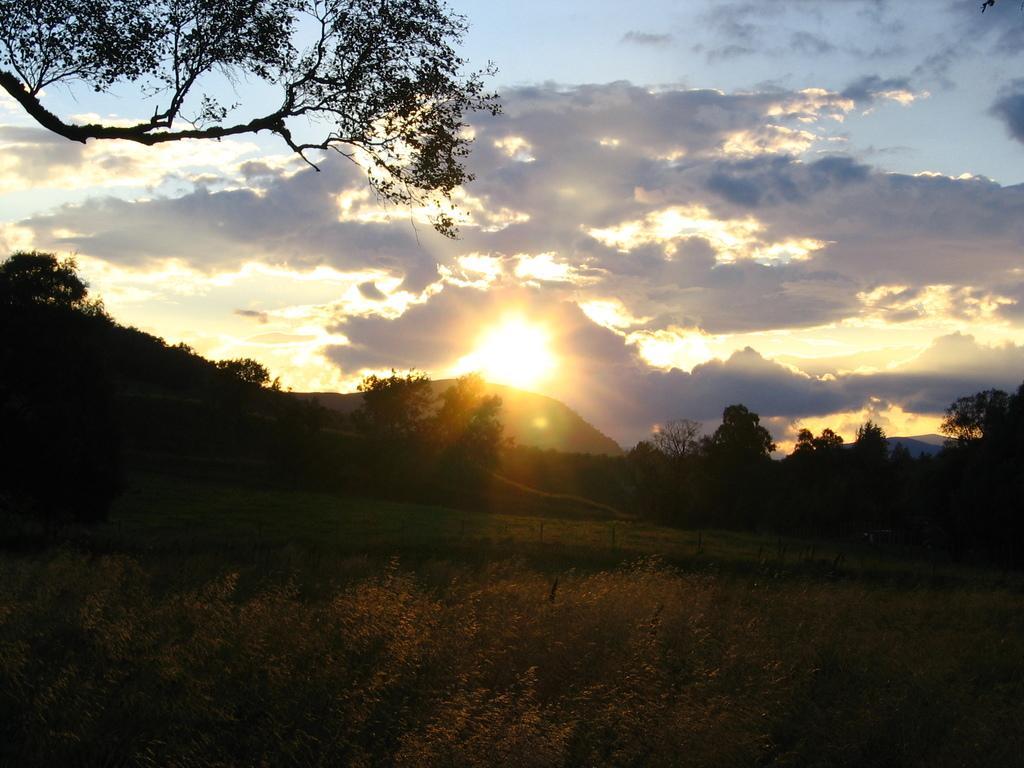Can you describe this image briefly? In this image we can see some plants, trees, mountains and grass, in the background, we can see the sun and the sky with clouds. 